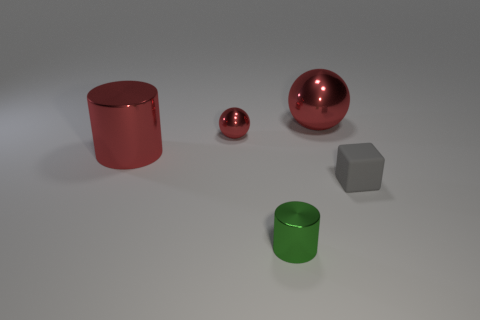Add 4 tiny blue rubber objects. How many objects exist? 9 Subtract all red cylinders. How many cylinders are left? 1 Subtract all cubes. How many objects are left? 4 Subtract all gray spheres. Subtract all brown cubes. How many spheres are left? 2 Subtract all tiny red balls. Subtract all green shiny cylinders. How many objects are left? 3 Add 2 rubber blocks. How many rubber blocks are left? 3 Add 3 shiny cylinders. How many shiny cylinders exist? 5 Subtract 0 yellow balls. How many objects are left? 5 